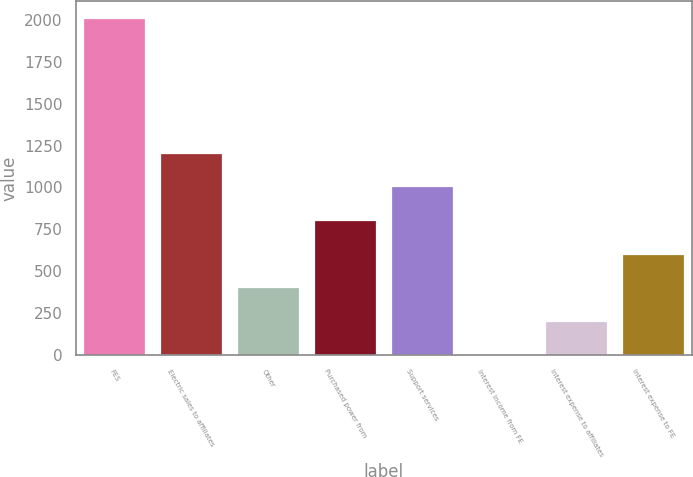<chart> <loc_0><loc_0><loc_500><loc_500><bar_chart><fcel>FES<fcel>Electric sales to affiliates<fcel>Other<fcel>Purchased power from<fcel>Support services<fcel>Interest income from FE<fcel>Interest expense to affiliates<fcel>Interest expense to FE<nl><fcel>2013<fcel>1208.6<fcel>404.2<fcel>806.4<fcel>1007.5<fcel>2<fcel>203.1<fcel>605.3<nl></chart> 